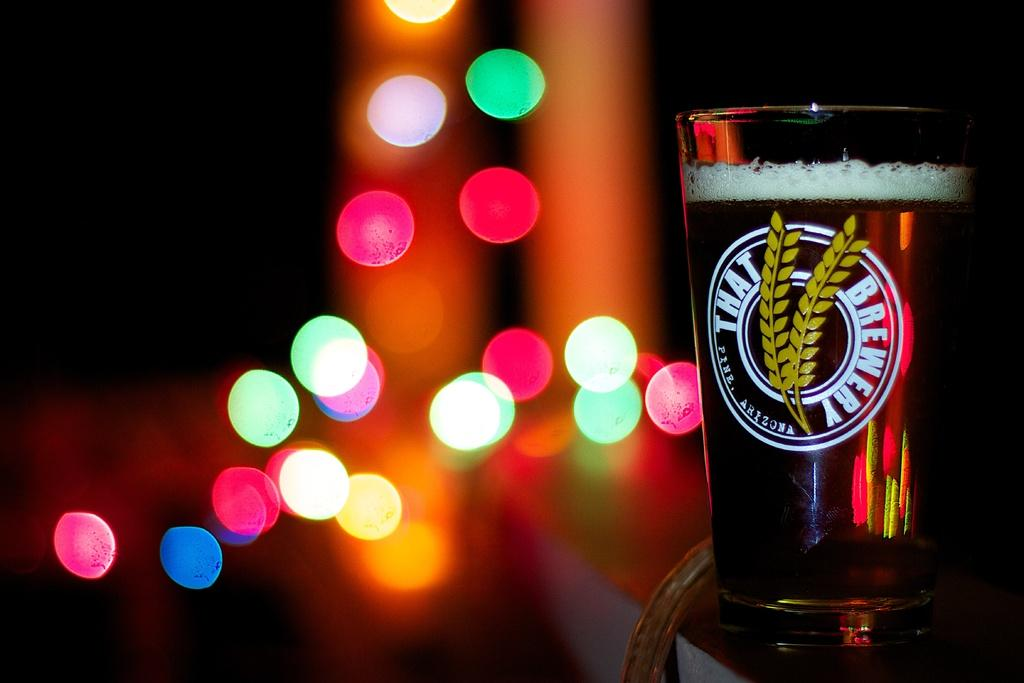Provide a one-sentence caption for the provided image. The That Brewery of Pine, Arizona, glass of beer is full. 